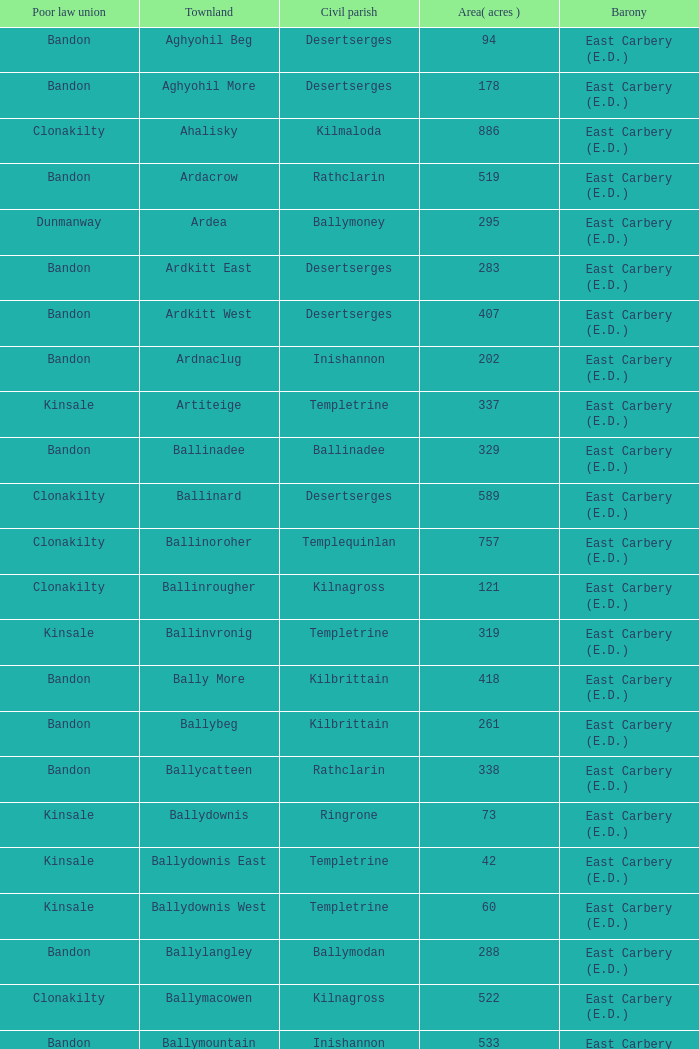What is the maximum area (in acres) of the Knockacullen townland? 381.0. 